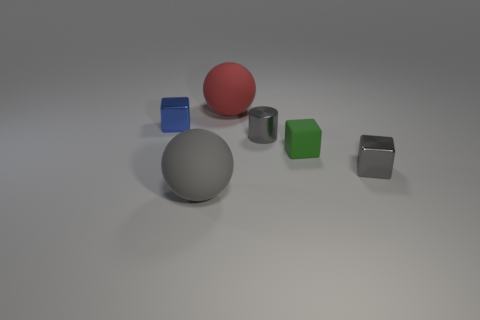Add 2 small brown metal cylinders. How many objects exist? 8 Subtract all spheres. How many objects are left? 4 Subtract 1 red balls. How many objects are left? 5 Subtract all large red matte spheres. Subtract all gray blocks. How many objects are left? 4 Add 2 gray rubber objects. How many gray rubber objects are left? 3 Add 1 gray matte balls. How many gray matte balls exist? 2 